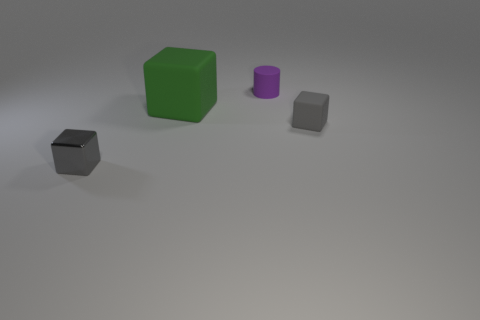Subtract all small matte cubes. How many cubes are left? 2 Add 3 gray objects. How many gray objects exist? 5 Add 4 big cubes. How many objects exist? 8 Subtract all green cubes. How many cubes are left? 2 Subtract 0 purple spheres. How many objects are left? 4 Subtract all blocks. How many objects are left? 1 Subtract 1 cubes. How many cubes are left? 2 Subtract all red cylinders. Subtract all cyan spheres. How many cylinders are left? 1 Subtract all red balls. How many gray cubes are left? 2 Subtract all tiny purple blocks. Subtract all gray metal things. How many objects are left? 3 